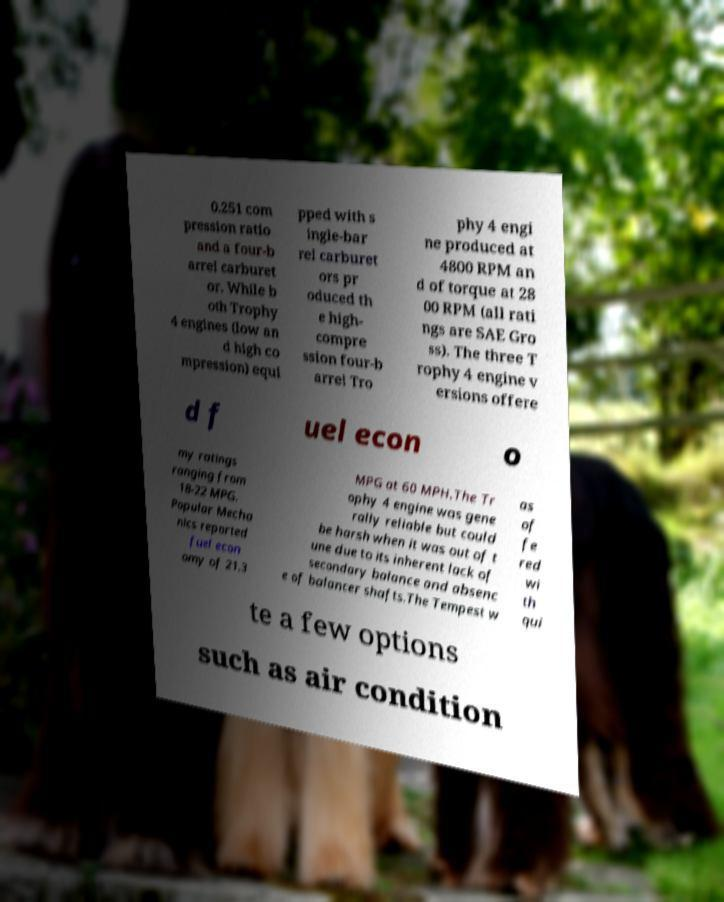Please read and relay the text visible in this image. What does it say? 0.251 com pression ratio and a four-b arrel carburet or. While b oth Trophy 4 engines (low an d high co mpression) equi pped with s ingle-bar rel carburet ors pr oduced th e high- compre ssion four-b arrel Tro phy 4 engi ne produced at 4800 RPM an d of torque at 28 00 RPM (all rati ngs are SAE Gro ss). The three T rophy 4 engine v ersions offere d f uel econ o my ratings ranging from 18-22 MPG. Popular Mecha nics reported fuel econ omy of 21.3 MPG at 60 MPH.The Tr ophy 4 engine was gene rally reliable but could be harsh when it was out of t une due to its inherent lack of secondary balance and absenc e of balancer shafts.The Tempest w as of fe red wi th qui te a few options such as air condition 